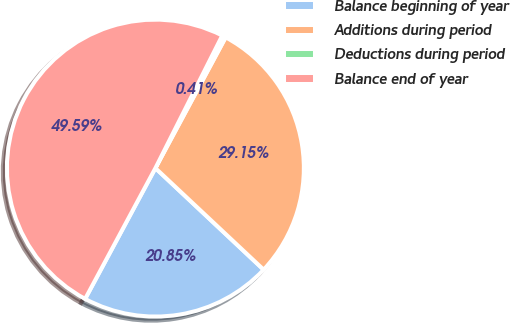<chart> <loc_0><loc_0><loc_500><loc_500><pie_chart><fcel>Balance beginning of year<fcel>Additions during period<fcel>Deductions during period<fcel>Balance end of year<nl><fcel>20.85%<fcel>29.15%<fcel>0.41%<fcel>49.59%<nl></chart> 